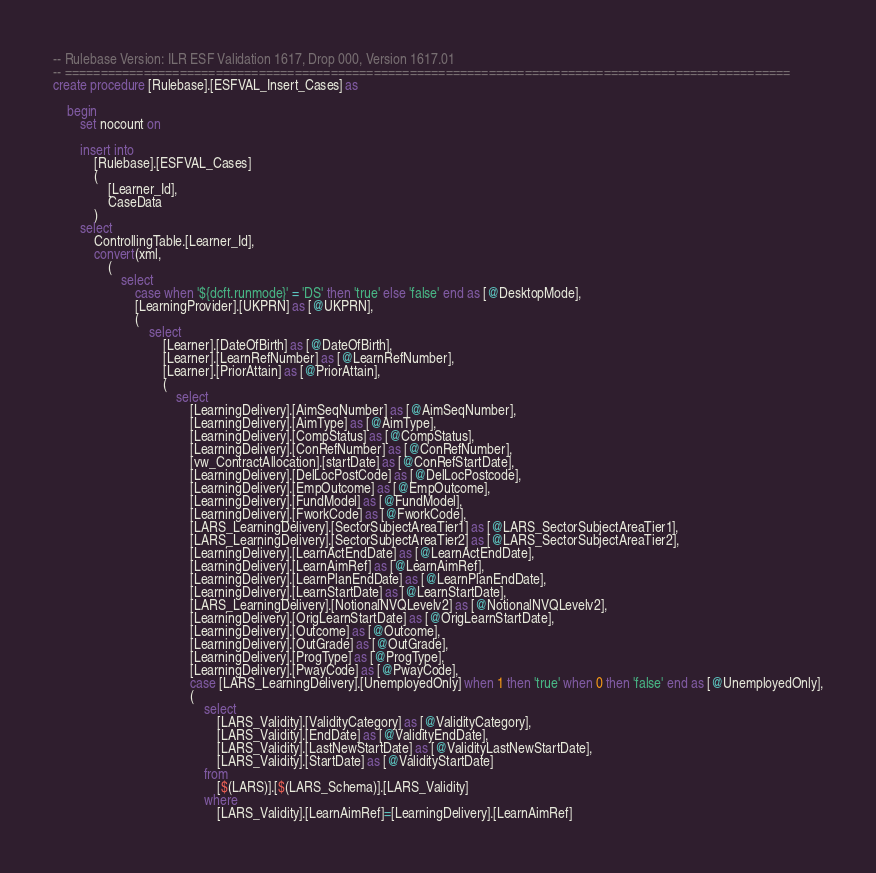<code> <loc_0><loc_0><loc_500><loc_500><_SQL_>-- Rulebase Version: ILR ESF Validation 1617, Drop 000, Version 1617.01
-- =====================================================================================================
create procedure [Rulebase].[ESFVAL_Insert_Cases] as

	begin
		set nocount on

		insert into
			[Rulebase].[ESFVAL_Cases]
			(
				[Learner_Id],
				CaseData
			)
		select
			ControllingTable.[Learner_Id],
			convert(xml,
				(
					select
						case when '${dcft.runmode}' = 'DS' then 'true' else 'false' end as [@DesktopMode],
						[LearningProvider].[UKPRN] as [@UKPRN],
						(
							select
								[Learner].[DateOfBirth] as [@DateOfBirth],
								[Learner].[LearnRefNumber] as [@LearnRefNumber],
								[Learner].[PriorAttain] as [@PriorAttain],
								(
									select
										[LearningDelivery].[AimSeqNumber] as [@AimSeqNumber],
										[LearningDelivery].[AimType] as [@AimType],
										[LearningDelivery].[CompStatus] as [@CompStatus],
										[LearningDelivery].[ConRefNumber] as [@ConRefNumber],
										[vw_ContractAllocation].[startDate] as [@ConRefStartDate],
										[LearningDelivery].[DelLocPostCode] as [@DelLocPostcode],
										[LearningDelivery].[EmpOutcome] as [@EmpOutcome],
										[LearningDelivery].[FundModel] as [@FundModel],
										[LearningDelivery].[FworkCode] as [@FworkCode],
										[LARS_LearningDelivery].[SectorSubjectAreaTier1] as [@LARS_SectorSubjectAreaTier1],
										[LARS_LearningDelivery].[SectorSubjectAreaTier2] as [@LARS_SectorSubjectAreaTier2],
										[LearningDelivery].[LearnActEndDate] as [@LearnActEndDate],
										[LearningDelivery].[LearnAimRef] as [@LearnAimRef],
										[LearningDelivery].[LearnPlanEndDate] as [@LearnPlanEndDate],
										[LearningDelivery].[LearnStartDate] as [@LearnStartDate],
										[LARS_LearningDelivery].[NotionalNVQLevelv2] as [@NotionalNVQLevelv2],
										[LearningDelivery].[OrigLearnStartDate] as [@OrigLearnStartDate],
										[LearningDelivery].[Outcome] as [@Outcome],
										[LearningDelivery].[OutGrade] as [@OutGrade],
										[LearningDelivery].[ProgType] as [@ProgType],
										[LearningDelivery].[PwayCode] as [@PwayCode],
										case [LARS_LearningDelivery].[UnemployedOnly] when 1 then 'true' when 0 then 'false' end as [@UnemployedOnly],
										(
											select
												[LARS_Validity].[ValidityCategory] as [@ValidityCategory],
												[LARS_Validity].[EndDate] as [@ValidityEndDate],
												[LARS_Validity].[LastNewStartDate] as [@ValidityLastNewStartDate],
												[LARS_Validity].[StartDate] as [@ValidityStartDate]
											from
												[$(LARS)].[$(LARS_Schema)].[LARS_Validity]
											where
												[LARS_Validity].[LearnAimRef]=[LearningDelivery].[LearnAimRef]</code> 